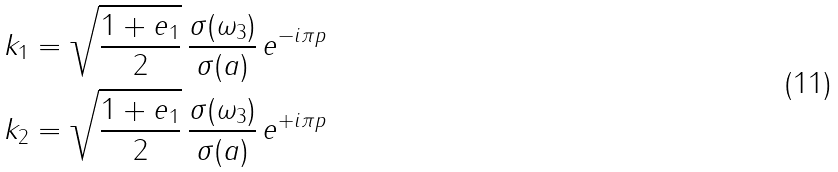<formula> <loc_0><loc_0><loc_500><loc_500>k _ { 1 } & = \sqrt { \frac { 1 + e _ { 1 } } { 2 } } \, \frac { \sigma ( \omega _ { 3 } ) } { \sigma ( a ) } \, e ^ { - i \pi p } \\ k _ { 2 } & = \sqrt { \frac { 1 + e _ { 1 } } { 2 } } \, \frac { \sigma ( \omega _ { 3 } ) } { \sigma ( a ) } \, e ^ { + i \pi p }</formula> 